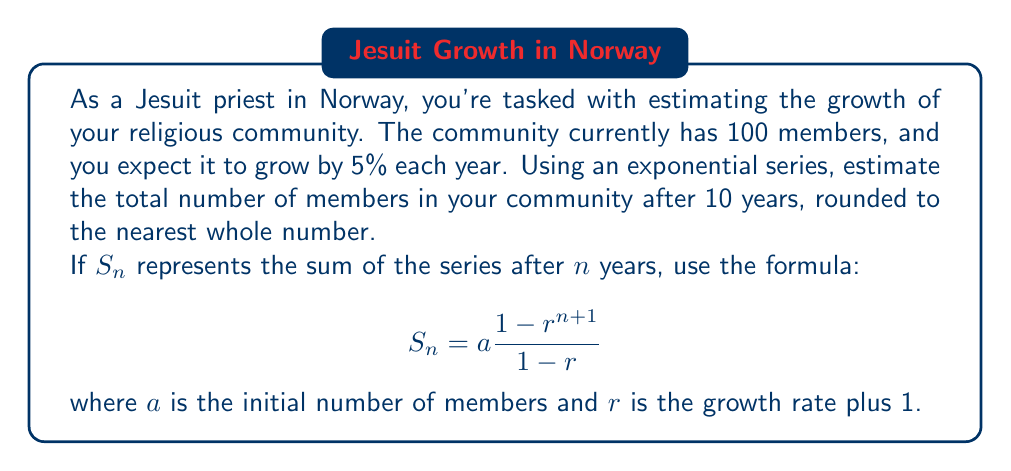Can you answer this question? To solve this problem, we'll use the formula for the sum of a geometric series:

$$S_n = a\frac{1-r^{n+1}}{1-r}$$

Where:
$a = 100$ (initial number of members)
$r = 1.05$ (growth rate of 5% plus 1)
$n = 10$ (number of years)

Let's substitute these values into the formula:

$$S_{10} = 100\frac{1-(1.05)^{11}}{1-1.05}$$

Now, let's calculate step by step:

1. Calculate $(1.05)^{11}$:
   $(1.05)^{11} \approx 1.7103$

2. Subtract this value from 1:
   $1 - 1.7103 = -0.7103$

3. Calculate the denominator:
   $1 - 1.05 = -0.05$

4. Divide the numerator by the denominator:
   $\frac{-0.7103}{-0.05} \approx 14.206$

5. Multiply by the initial number of members:
   $100 \times 14.206 \approx 1420.6$

6. Round to the nearest whole number:
   $1420.6 \approx 1421$

Therefore, after 10 years, the estimated number of members in the religious community would be 1421.
Answer: 1421 members 